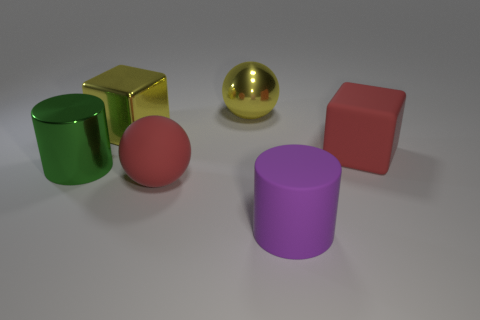What lighting conditions are present and how do they affect the objects? The lighting in the image is soft and diffused, coming from above. This creates gentle shadows beneath the objects and highlights on their tops, emphasizing their shapes without creating harsh reflections - except for the reflective sphere, which has a strong highlight, reflecting the light source. Assuming these objects represent different materials, what could each one be made of based on their appearance? The green and purple cylinders might be made of a matte plastic due to their even, non-reflective surfaces. The golden cube could be a metallic material given its shiny, reflective qualities. The reflective sphere also appears metallic, with its mirror-like finish. Lastly, the pink cube could be either a matte painted wood or plastic, given its lack of substantial reflection. 